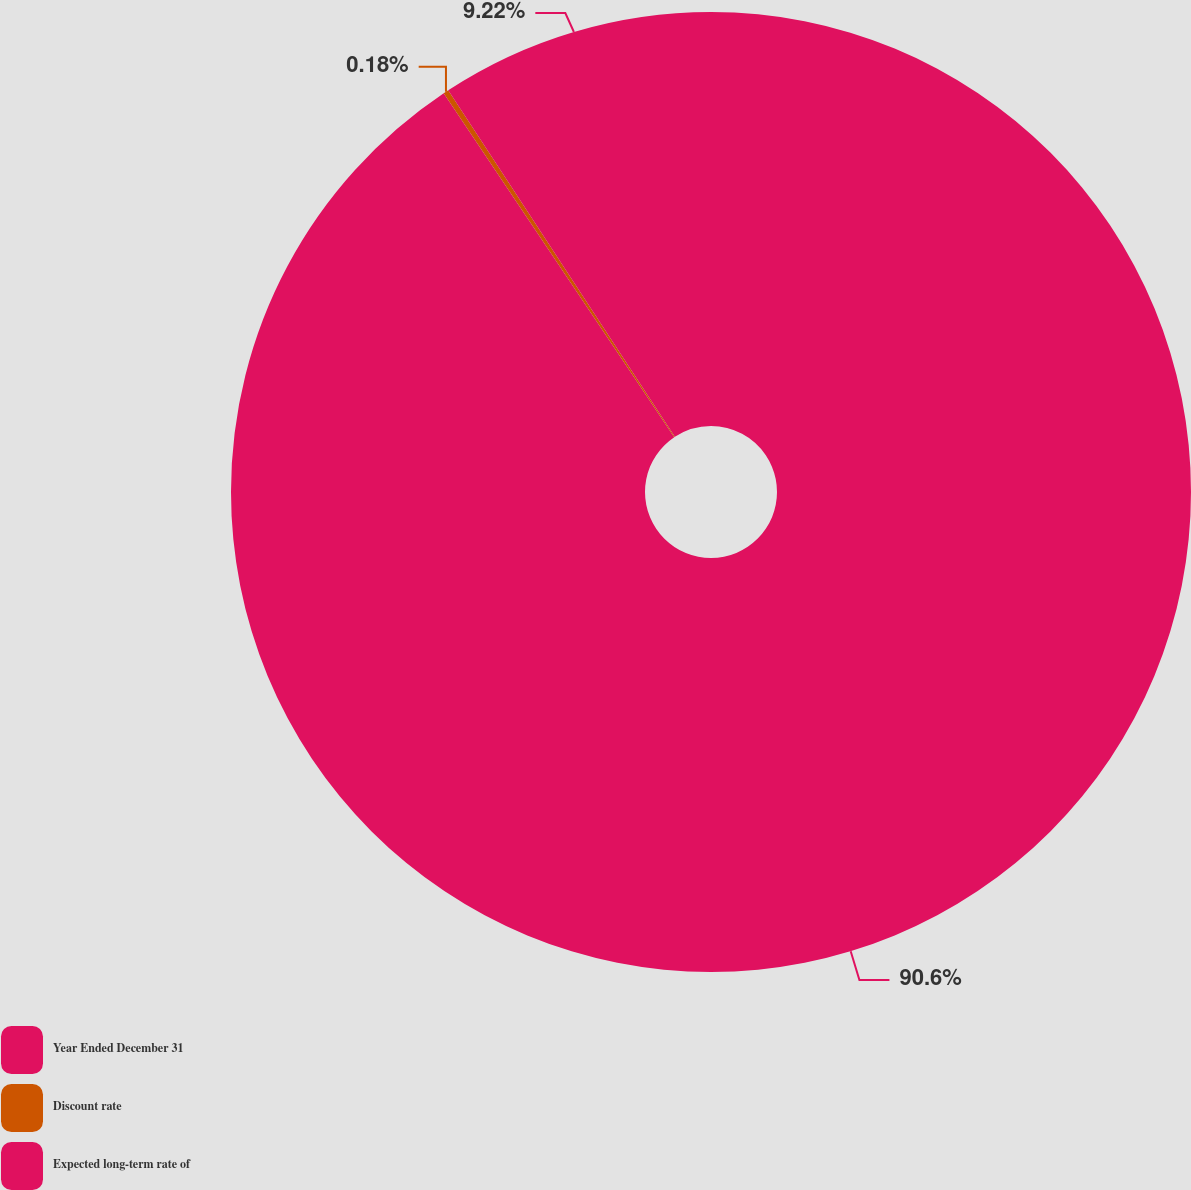<chart> <loc_0><loc_0><loc_500><loc_500><pie_chart><fcel>Year Ended December 31<fcel>Discount rate<fcel>Expected long-term rate of<nl><fcel>90.6%<fcel>0.18%<fcel>9.22%<nl></chart> 